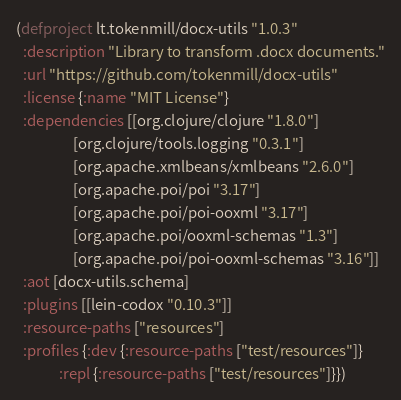Convert code to text. <code><loc_0><loc_0><loc_500><loc_500><_Clojure_>(defproject lt.tokenmill/docx-utils "1.0.3"
  :description "Library to transform .docx documents."
  :url "https://github.com/tokenmill/docx-utils"
  :license {:name "MIT License"}
  :dependencies [[org.clojure/clojure "1.8.0"]
                 [org.clojure/tools.logging "0.3.1"]
                 [org.apache.xmlbeans/xmlbeans "2.6.0"]
                 [org.apache.poi/poi "3.17"]
                 [org.apache.poi/poi-ooxml "3.17"]
                 [org.apache.poi/ooxml-schemas "1.3"]
                 [org.apache.poi/poi-ooxml-schemas "3.16"]]
  :aot [docx-utils.schema]
  :plugins [[lein-codox "0.10.3"]]
  :resource-paths ["resources"]
  :profiles {:dev {:resource-paths ["test/resources"]}
             :repl {:resource-paths ["test/resources"]}})
</code> 